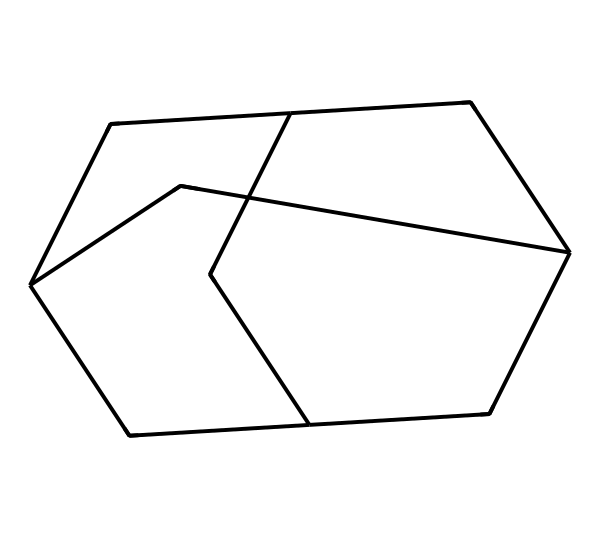What is the molecular formula of adamantane? To determine the molecular formula, count the number of carbon (C) and hydrogen (H) atoms in the structure. Adamantane consists of 10 carbon atoms and 16 hydrogen atoms. Therefore, the molecular formula is C10H16.
Answer: C10H16 How many rings are present in adamantane? Adamantane has a bridged structure made up of three interconnected cyclohexane rings. Therefore, it consists of three rings.
Answer: three What is the hybridization of the carbon atoms in adamantane? Each carbon atom in adamantane is involved in four sigma bonds, consistent with sp3 hybridization, as they are tetrahedral. Thus, the hybridization of the carbon atoms is sp3.
Answer: sp3 Why does adamantane exhibit a high melting point? Adamantane has a highly symmetrical and compact structure that allows for strong van der Waals forces between molecules, leading to a higher melting point compared to other hydrocarbons with similar molecular weight.
Answer: high van der Waals forces How many hydrogen atoms are there per carbon in adamantane? To find the ratio of hydrogen to carbon atoms, divide the total number of hydrogen atoms (16) by the total number of carbon atoms (10). This results in a hydrogen to carbon ratio of 1.6.
Answer: 1.6 What unique structural feature defines adamantane as a bridged cycloalkane? Adamantane features a 3D arrangement of cycloalkane units fused together by bridgehead carbon atoms, making it a bridged cycloalkane. This distinct structural feature sets it apart from other cycloalkanes.
Answer: bridged structure What type of bonding predominates in adamantane? The carbon and hydrogen atoms in adamantane are primarily held together by covalent bonds, as each atom shares electrons to achieve stability in its molecular structure.
Answer: covalent bonds 